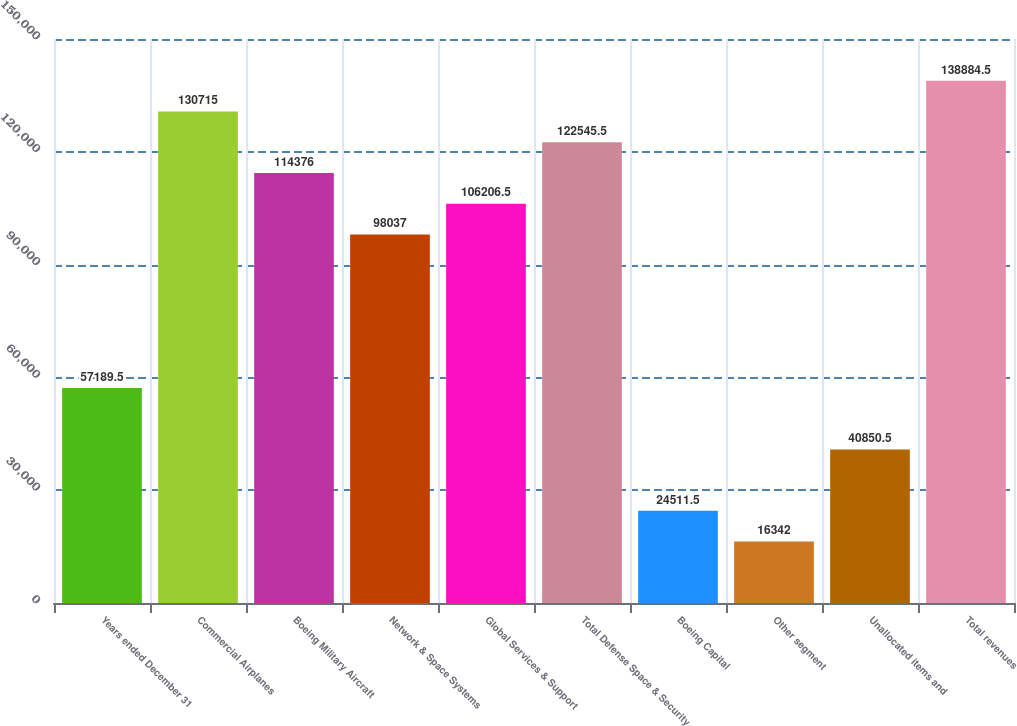<chart> <loc_0><loc_0><loc_500><loc_500><bar_chart><fcel>Years ended December 31<fcel>Commercial Airplanes<fcel>Boeing Military Aircraft<fcel>Network & Space Systems<fcel>Global Services & Support<fcel>Total Defense Space & Security<fcel>Boeing Capital<fcel>Other segment<fcel>Unallocated items and<fcel>Total revenues<nl><fcel>57189.5<fcel>130715<fcel>114376<fcel>98037<fcel>106206<fcel>122546<fcel>24511.5<fcel>16342<fcel>40850.5<fcel>138884<nl></chart> 